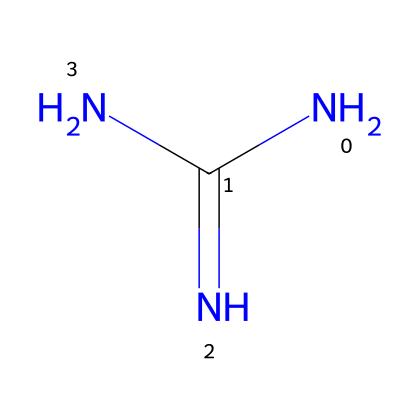What is the main functional group in guanidine? The guanidine structure contains a carbon atom double-bonded to a nitrogen atom (C=NH), which is characteristic of an imine functional group. This group defines the reactivity and properties of guanidine.
Answer: imine How many nitrogen atoms are present in guanidine? By analyzing the SMILES representation, there are three nitrogen atoms indicated in the chemical structure. Each nitrogen contributes to the basicity and various industrial applications of guanidine.
Answer: three What is the total number of atoms in guanidine? In the chemical formula derived from the SMILES, guanidine has a total of five atoms: one carbon and four nitrogen atoms (1C + 4N = 5). This count includes all elements present in the molecule.
Answer: five What type of base is guanidine classified as? Guanidine has multiple nitrogen atoms that possess lone pairs, allowing it to accept protons readily, which qualifies it as a superbasic compound. This classification is important in industrial applications where strong bases are necessary.
Answer: superbasic What is the hybridization of the nitrogen atom connected to the carbon in guanidine? The nitrogen atom is sp2 hybridized due to its involvement in a double bond with carbon and having one lone pair of electrons, affecting the bond angles and overall structure of the molecule. This hybridization also impacts its reactivity.
Answer: sp2 What is guanidine primarily used for in industrial applications? Given its strong basic character, guanidine is primarily used as an intermediate in the production of pharmaceuticals and in the formulation of various agrochemicals, impacting agricultural and medical sectors.
Answer: intermediate Which type of reaction is guanidine commonly involved in due to its basic properties? The basicity of guanidine makes it suitable for catalyzing reactions such as nucleophilic substitutions, which are common in organic synthesis, allowing for the formation of diverse chemical bonds and compounds.
Answer: nucleophilic substitution 